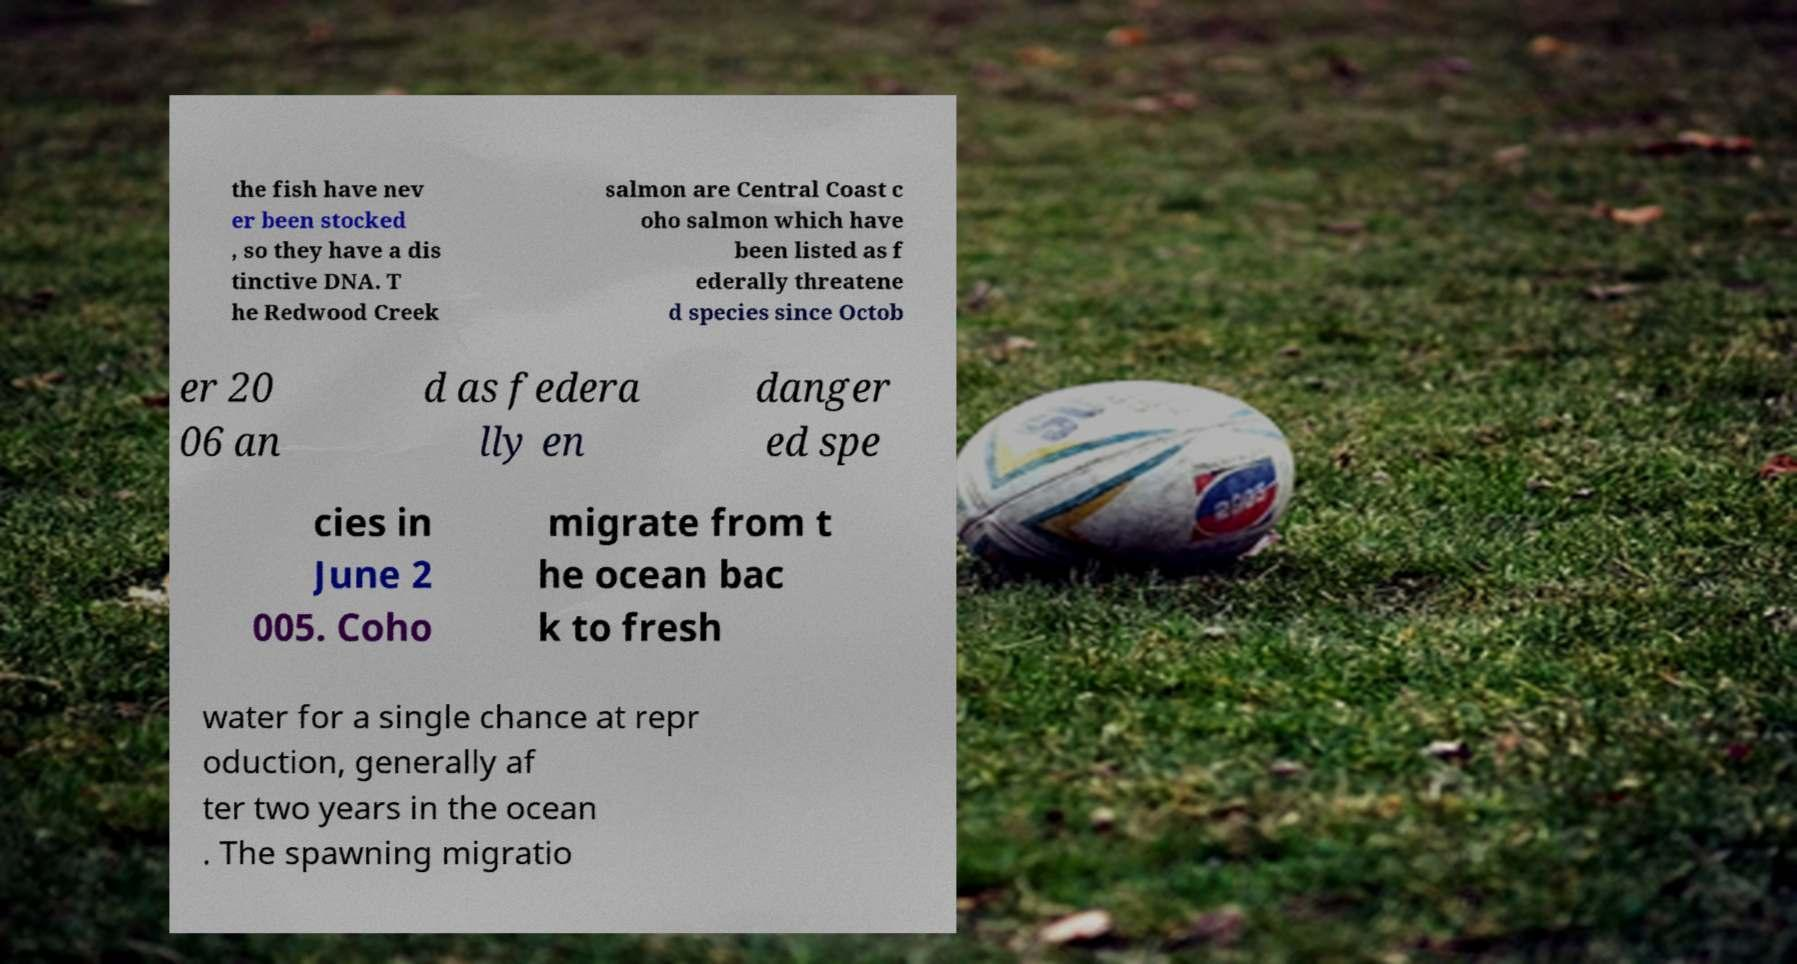Could you assist in decoding the text presented in this image and type it out clearly? the fish have nev er been stocked , so they have a dis tinctive DNA. T he Redwood Creek salmon are Central Coast c oho salmon which have been listed as f ederally threatene d species since Octob er 20 06 an d as federa lly en danger ed spe cies in June 2 005. Coho migrate from t he ocean bac k to fresh water for a single chance at repr oduction, generally af ter two years in the ocean . The spawning migratio 